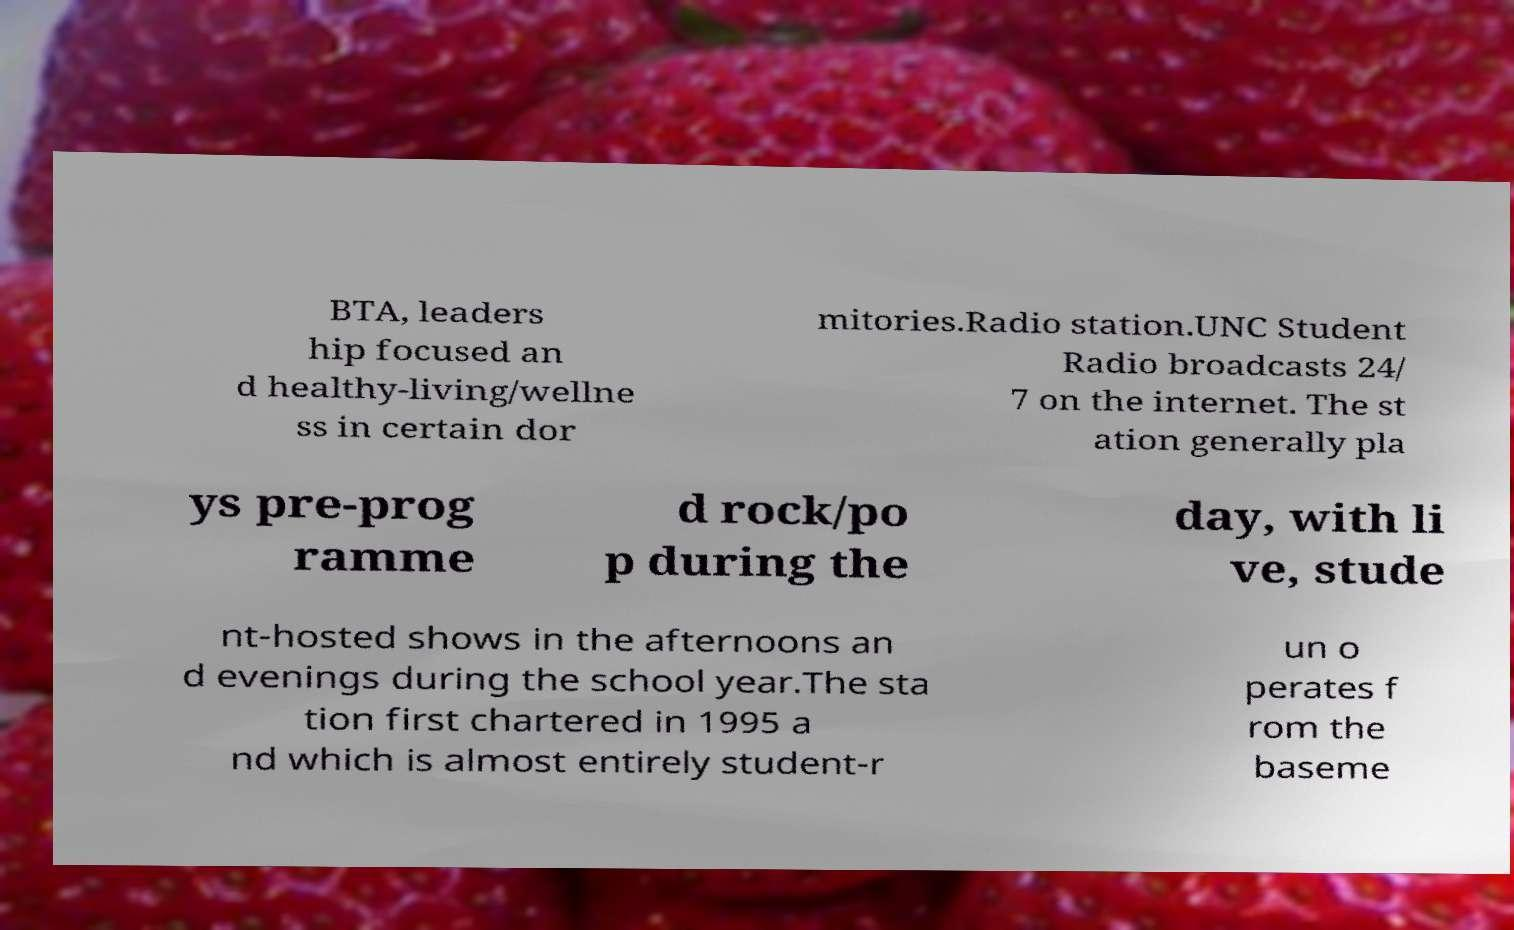What messages or text are displayed in this image? I need them in a readable, typed format. BTA, leaders hip focused an d healthy-living/wellne ss in certain dor mitories.Radio station.UNC Student Radio broadcasts 24/ 7 on the internet. The st ation generally pla ys pre-prog ramme d rock/po p during the day, with li ve, stude nt-hosted shows in the afternoons an d evenings during the school year.The sta tion first chartered in 1995 a nd which is almost entirely student-r un o perates f rom the baseme 